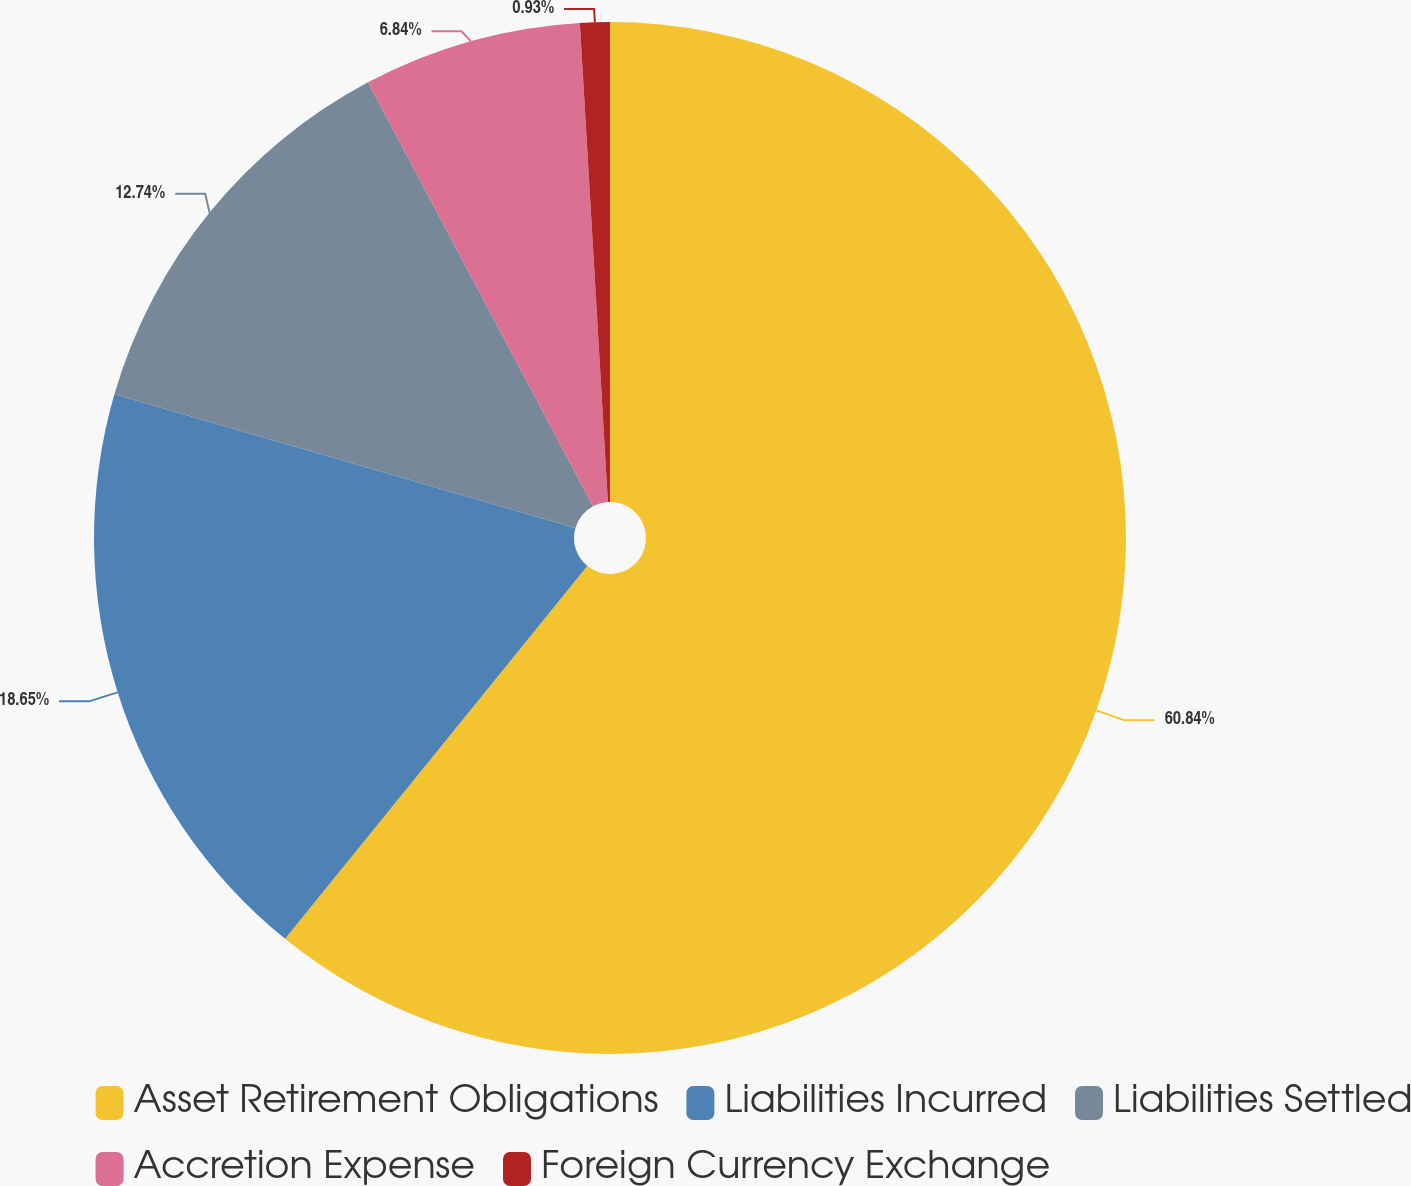Convert chart to OTSL. <chart><loc_0><loc_0><loc_500><loc_500><pie_chart><fcel>Asset Retirement Obligations<fcel>Liabilities Incurred<fcel>Liabilities Settled<fcel>Accretion Expense<fcel>Foreign Currency Exchange<nl><fcel>60.84%<fcel>18.65%<fcel>12.74%<fcel>6.84%<fcel>0.93%<nl></chart> 